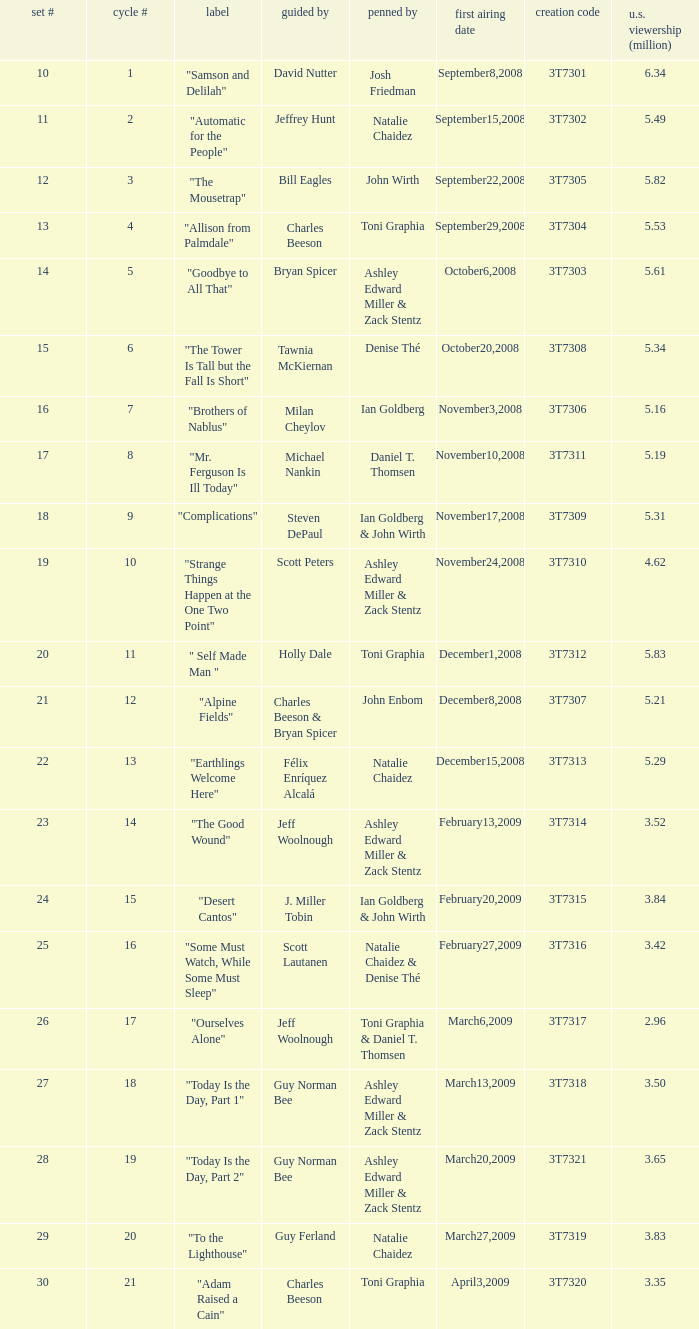Which episode number was directed by Bill Eagles? 12.0. 